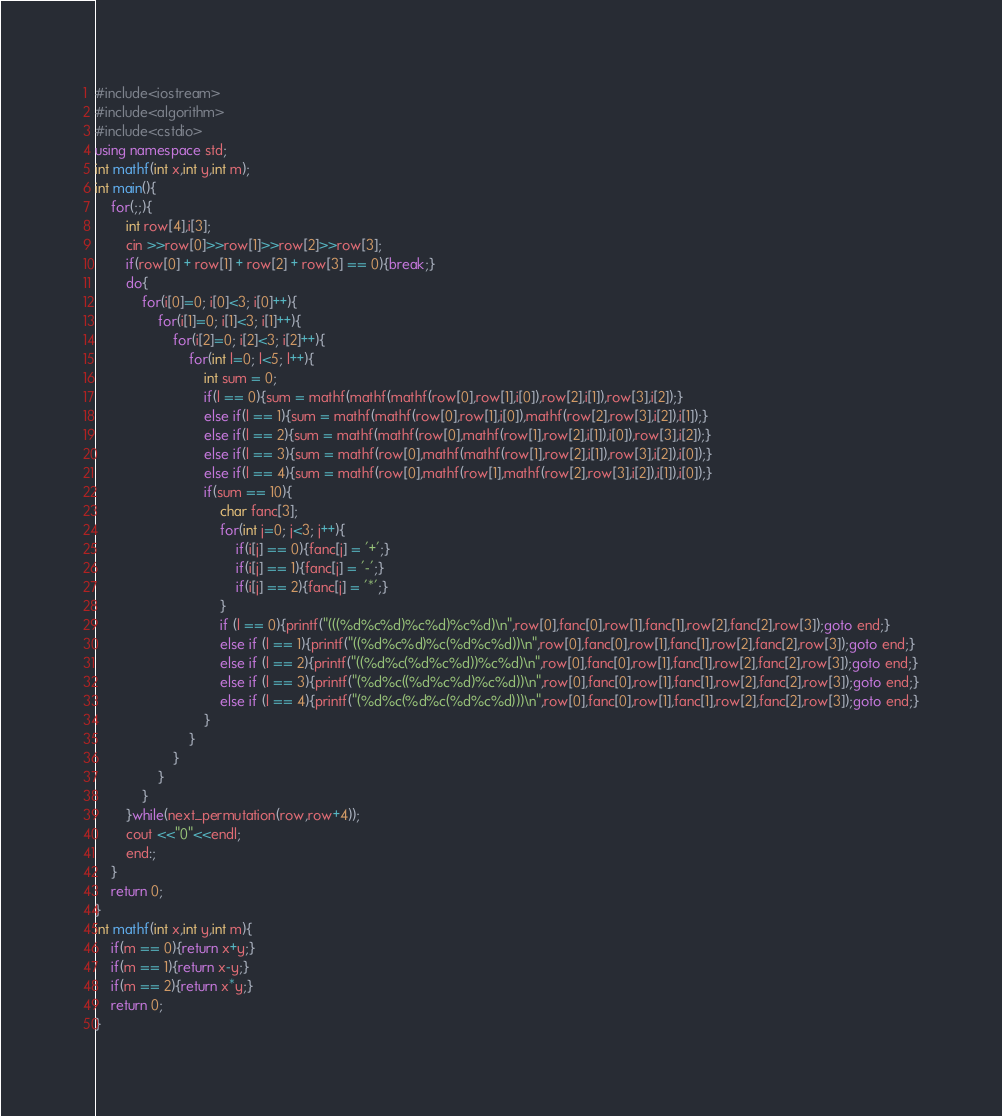Convert code to text. <code><loc_0><loc_0><loc_500><loc_500><_C++_>#include<iostream>
#include<algorithm>
#include<cstdio>
using namespace std;
int mathf(int x,int y,int m);
int main(){
	for(;;){
		int row[4],i[3];
		cin >>row[0]>>row[1]>>row[2]>>row[3];
		if(row[0] + row[1] + row[2] + row[3] == 0){break;}
		do{
			for(i[0]=0; i[0]<3; i[0]++){
				for(i[1]=0; i[1]<3; i[1]++){
					for(i[2]=0; i[2]<3; i[2]++){
						for(int l=0; l<5; l++){
							int sum = 0;
							if(l == 0){sum = mathf(mathf(mathf(row[0],row[1],i[0]),row[2],i[1]),row[3],i[2]);}
							else if(l == 1){sum = mathf(mathf(row[0],row[1],i[0]),mathf(row[2],row[3],i[2]),i[1]);}
							else if(l == 2){sum = mathf(mathf(row[0],mathf(row[1],row[2],i[1]),i[0]),row[3],i[2]);}
							else if(l == 3){sum = mathf(row[0],mathf(mathf(row[1],row[2],i[1]),row[3],i[2]),i[0]);}
							else if(l == 4){sum = mathf(row[0],mathf(row[1],mathf(row[2],row[3],i[2]),i[1]),i[0]);}
							if(sum == 10){
								char fanc[3];
								for(int j=0; j<3; j++){
									if(i[j] == 0){fanc[j] = '+';}
									if(i[j] == 1){fanc[j] = '-';}
									if(i[j] == 2){fanc[j] = '*';}
								}
								if (l == 0){printf("(((%d%c%d)%c%d)%c%d)\n",row[0],fanc[0],row[1],fanc[1],row[2],fanc[2],row[3]);goto end;}
								else if (l == 1){printf("((%d%c%d)%c(%d%c%d))\n",row[0],fanc[0],row[1],fanc[1],row[2],fanc[2],row[3]);goto end;}
								else if (l == 2){printf("((%d%c(%d%c%d))%c%d)\n",row[0],fanc[0],row[1],fanc[1],row[2],fanc[2],row[3]);goto end;}
								else if (l == 3){printf("(%d%c((%d%c%d)%c%d))\n",row[0],fanc[0],row[1],fanc[1],row[2],fanc[2],row[3]);goto end;}
								else if (l == 4){printf("(%d%c(%d%c(%d%c%d)))\n",row[0],fanc[0],row[1],fanc[1],row[2],fanc[2],row[3]);goto end;}
							}
						}
					}
				}
			}
		}while(next_permutation(row,row+4));
		cout <<"0"<<endl;
		end:;
	}
	return 0;
}
int mathf(int x,int y,int m){
	if(m == 0){return x+y;}
	if(m == 1){return x-y;}
	if(m == 2){return x*y;}
	return 0;
}</code> 